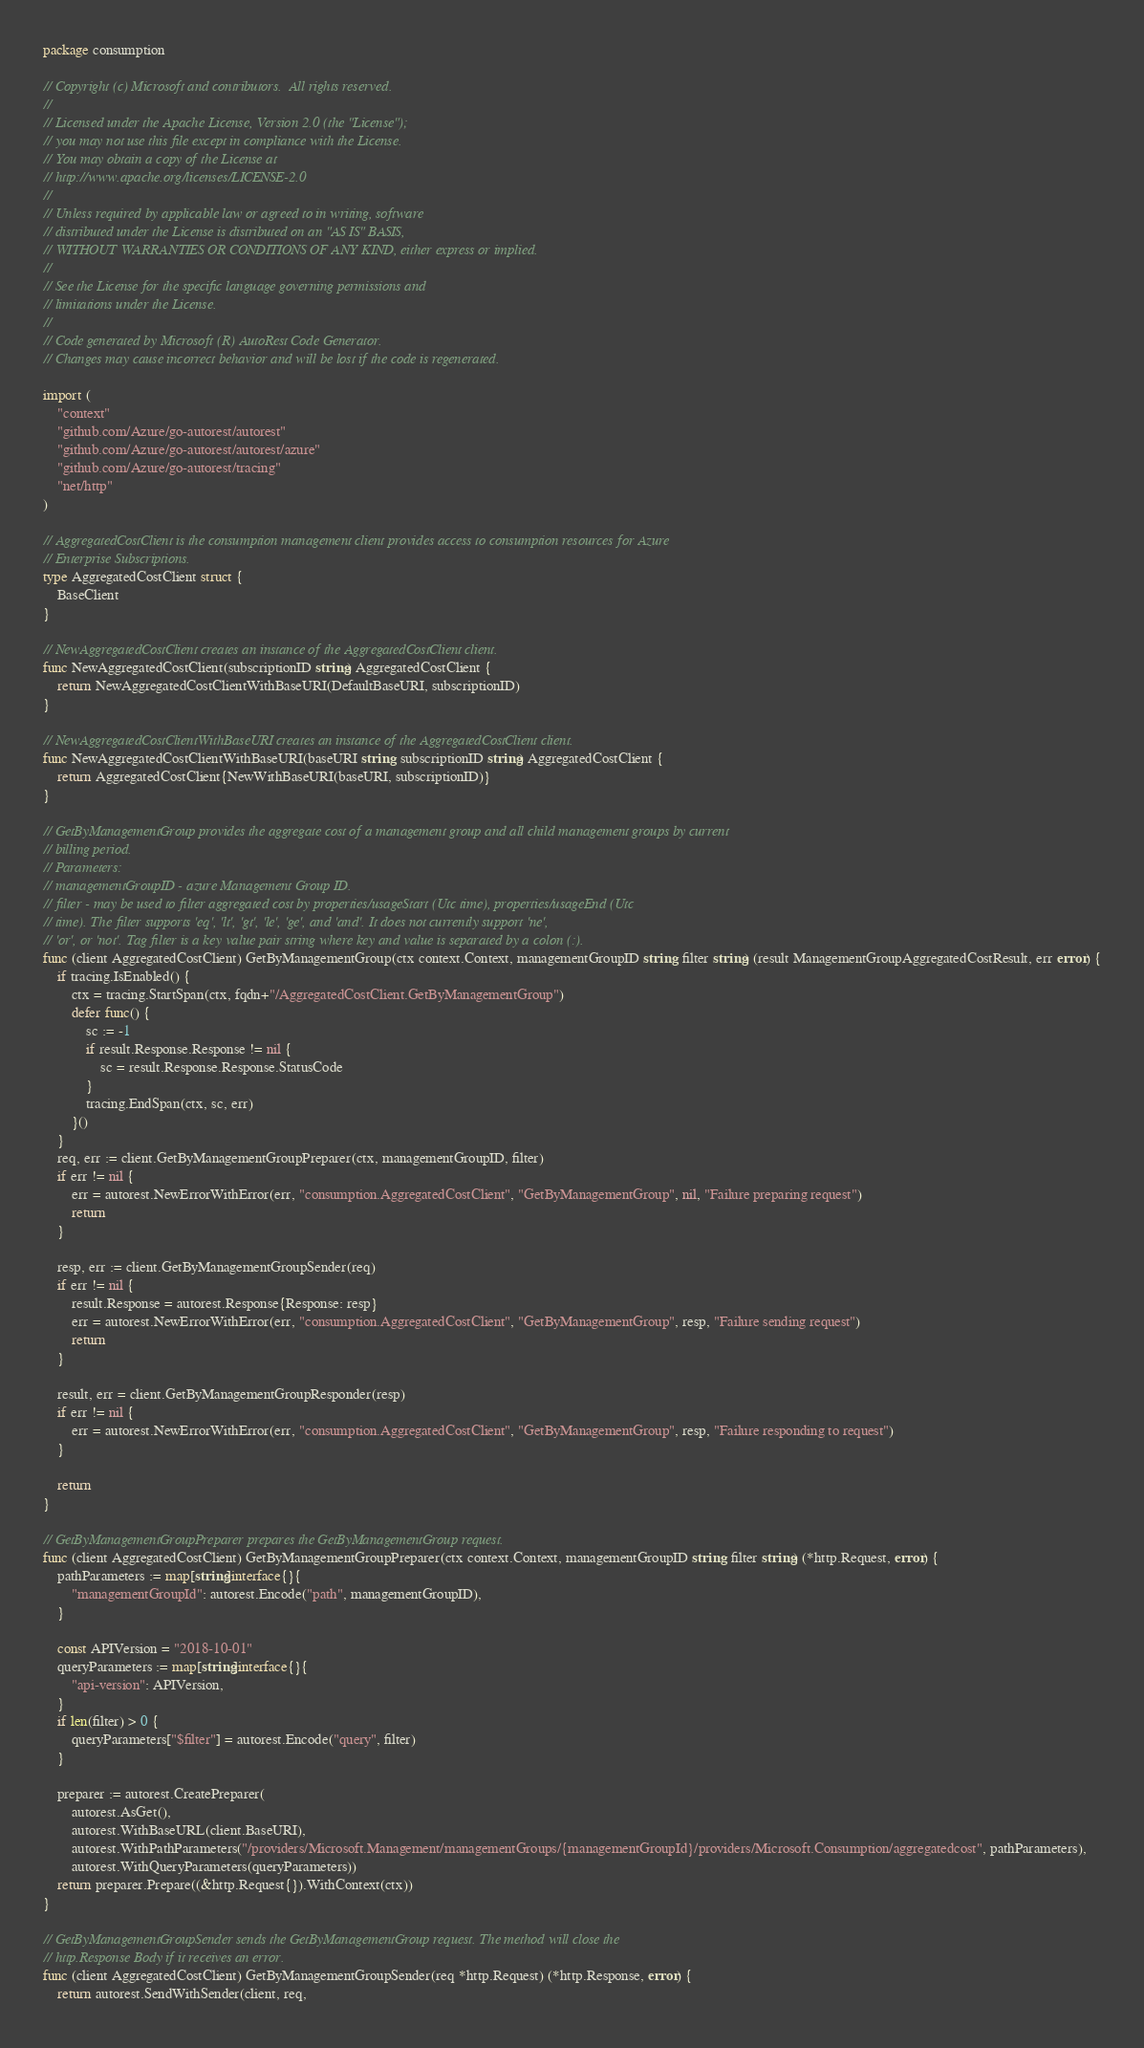Convert code to text. <code><loc_0><loc_0><loc_500><loc_500><_Go_>package consumption

// Copyright (c) Microsoft and contributors.  All rights reserved.
//
// Licensed under the Apache License, Version 2.0 (the "License");
// you may not use this file except in compliance with the License.
// You may obtain a copy of the License at
// http://www.apache.org/licenses/LICENSE-2.0
//
// Unless required by applicable law or agreed to in writing, software
// distributed under the License is distributed on an "AS IS" BASIS,
// WITHOUT WARRANTIES OR CONDITIONS OF ANY KIND, either express or implied.
//
// See the License for the specific language governing permissions and
// limitations under the License.
//
// Code generated by Microsoft (R) AutoRest Code Generator.
// Changes may cause incorrect behavior and will be lost if the code is regenerated.

import (
	"context"
	"github.com/Azure/go-autorest/autorest"
	"github.com/Azure/go-autorest/autorest/azure"
	"github.com/Azure/go-autorest/tracing"
	"net/http"
)

// AggregatedCostClient is the consumption management client provides access to consumption resources for Azure
// Enterprise Subscriptions.
type AggregatedCostClient struct {
	BaseClient
}

// NewAggregatedCostClient creates an instance of the AggregatedCostClient client.
func NewAggregatedCostClient(subscriptionID string) AggregatedCostClient {
	return NewAggregatedCostClientWithBaseURI(DefaultBaseURI, subscriptionID)
}

// NewAggregatedCostClientWithBaseURI creates an instance of the AggregatedCostClient client.
func NewAggregatedCostClientWithBaseURI(baseURI string, subscriptionID string) AggregatedCostClient {
	return AggregatedCostClient{NewWithBaseURI(baseURI, subscriptionID)}
}

// GetByManagementGroup provides the aggregate cost of a management group and all child management groups by current
// billing period.
// Parameters:
// managementGroupID - azure Management Group ID.
// filter - may be used to filter aggregated cost by properties/usageStart (Utc time), properties/usageEnd (Utc
// time). The filter supports 'eq', 'lt', 'gt', 'le', 'ge', and 'and'. It does not currently support 'ne',
// 'or', or 'not'. Tag filter is a key value pair string where key and value is separated by a colon (:).
func (client AggregatedCostClient) GetByManagementGroup(ctx context.Context, managementGroupID string, filter string) (result ManagementGroupAggregatedCostResult, err error) {
	if tracing.IsEnabled() {
		ctx = tracing.StartSpan(ctx, fqdn+"/AggregatedCostClient.GetByManagementGroup")
		defer func() {
			sc := -1
			if result.Response.Response != nil {
				sc = result.Response.Response.StatusCode
			}
			tracing.EndSpan(ctx, sc, err)
		}()
	}
	req, err := client.GetByManagementGroupPreparer(ctx, managementGroupID, filter)
	if err != nil {
		err = autorest.NewErrorWithError(err, "consumption.AggregatedCostClient", "GetByManagementGroup", nil, "Failure preparing request")
		return
	}

	resp, err := client.GetByManagementGroupSender(req)
	if err != nil {
		result.Response = autorest.Response{Response: resp}
		err = autorest.NewErrorWithError(err, "consumption.AggregatedCostClient", "GetByManagementGroup", resp, "Failure sending request")
		return
	}

	result, err = client.GetByManagementGroupResponder(resp)
	if err != nil {
		err = autorest.NewErrorWithError(err, "consumption.AggregatedCostClient", "GetByManagementGroup", resp, "Failure responding to request")
	}

	return
}

// GetByManagementGroupPreparer prepares the GetByManagementGroup request.
func (client AggregatedCostClient) GetByManagementGroupPreparer(ctx context.Context, managementGroupID string, filter string) (*http.Request, error) {
	pathParameters := map[string]interface{}{
		"managementGroupId": autorest.Encode("path", managementGroupID),
	}

	const APIVersion = "2018-10-01"
	queryParameters := map[string]interface{}{
		"api-version": APIVersion,
	}
	if len(filter) > 0 {
		queryParameters["$filter"] = autorest.Encode("query", filter)
	}

	preparer := autorest.CreatePreparer(
		autorest.AsGet(),
		autorest.WithBaseURL(client.BaseURI),
		autorest.WithPathParameters("/providers/Microsoft.Management/managementGroups/{managementGroupId}/providers/Microsoft.Consumption/aggregatedcost", pathParameters),
		autorest.WithQueryParameters(queryParameters))
	return preparer.Prepare((&http.Request{}).WithContext(ctx))
}

// GetByManagementGroupSender sends the GetByManagementGroup request. The method will close the
// http.Response Body if it receives an error.
func (client AggregatedCostClient) GetByManagementGroupSender(req *http.Request) (*http.Response, error) {
	return autorest.SendWithSender(client, req,</code> 